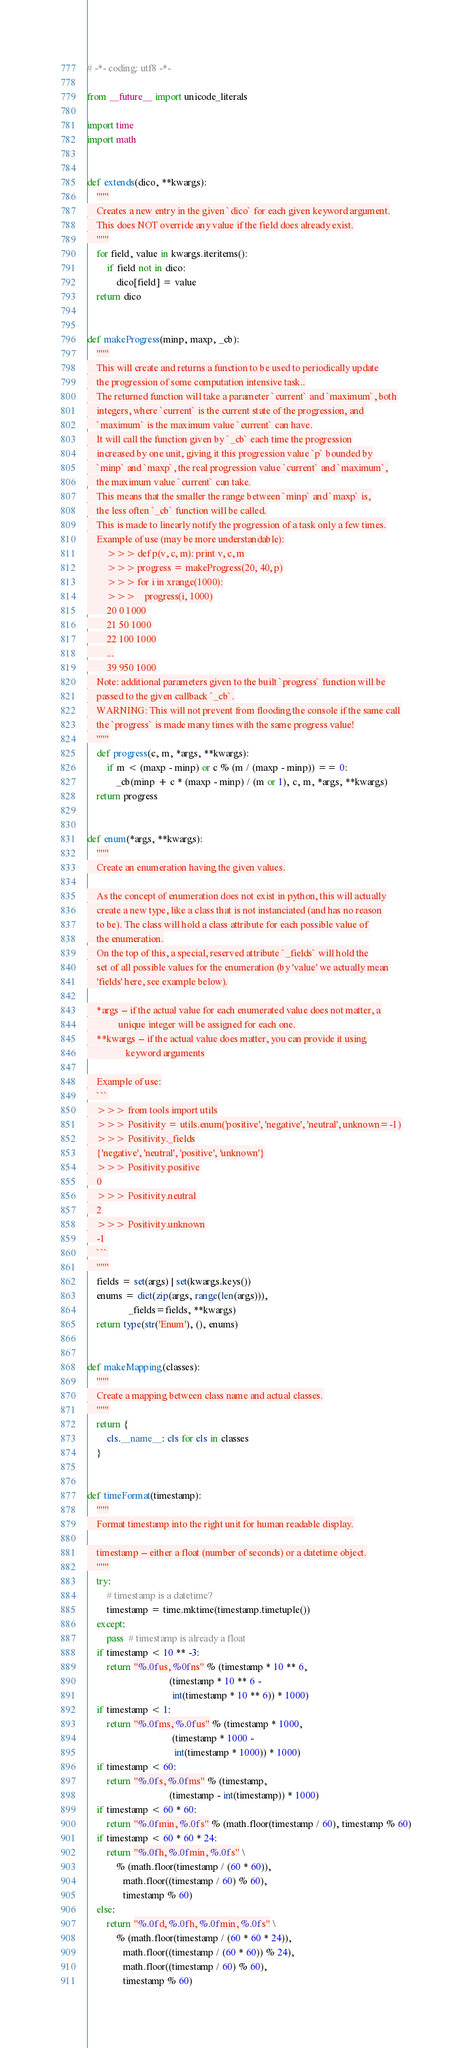<code> <loc_0><loc_0><loc_500><loc_500><_Python_># -*- coding: utf8 -*-

from __future__ import unicode_literals

import time
import math


def extends(dico, **kwargs):
    """
    Creates a new entry in the given `dico` for each given keyword argument.
    This does NOT override any value if the field does already exist.
    """
    for field, value in kwargs.iteritems():
        if field not in dico:
            dico[field] = value
    return dico


def makeProgress(minp, maxp, _cb):
    """
    This will create and returns a function to be used to periodically update
    the progression of some computation intensive task..
    The returned function will take a parameter `current` and `maximum`, both
    integers, where `current` is the current state of the progression, and
    `maximum` is the maximum value `current` can have.
    It will call the function given by `_cb` each time the progression
    increased by one unit, giving it this progression value `p` bounded by
    `minp` and `maxp`, the real progression value `current` and `maximum`,
    the maximum value `current` can take.
    This means that the smaller the range between `minp` and `maxp` is,
    the less often `_cb` function will be called.
    This is made to linearly notify the progression of a task only a few times.
    Example of use (may be more understandable):
        >>> def p(v, c, m): print v, c, m
        >>> progress = makeProgress(20, 40, p)
        >>> for i in xrange(1000):
        >>>    progress(i, 1000)
        20 0 1000
        21 50 1000
        22 100 1000
        ...
        39 950 1000
    Note: additional parameters given to the built `progress` function will be
    passed to the given callback `_cb`.
    WARNING: This will not prevent from flooding the console if the same call
    the `progress` is made many times with the same progress value!
    """
    def progress(c, m, *args, **kwargs):
        if m < (maxp - minp) or c % (m / (maxp - minp)) == 0:
            _cb(minp + c * (maxp - minp) / (m or 1), c, m, *args, **kwargs)
    return progress


def enum(*args, **kwargs):
    """
    Create an enumeration having the given values.

    As the concept of enumeration does not exist in python, this will actually
    create a new type, like a class that is not instanciated (and has no reason
    to be). The class will hold a class attribute for each possible value of
    the enumeration.
    On the top of this, a special, reserved attribute `_fields` will hold the
    set of all possible values for the enumeration (by 'value' we actually mean
    'fields' here, see example below).

    *args -- if the actual value for each enumerated value does not matter, a
             unique integer will be assigned for each one.
    **kwargs -- if the actual value does matter, you can provide it using
                keyword arguments

    Example of use:
    ```
    >>> from tools import utils
    >>> Positivity = utils.enum('positive', 'negative', 'neutral', unknown=-1)
    >>> Positivity._fields
    {'negative', 'neutral', 'positive', 'unknown'}
    >>> Positivity.positive
    0
    >>> Positivity.neutral
    2
    >>> Positivity.unknown
    -1
    ```
    """
    fields = set(args) | set(kwargs.keys())
    enums = dict(zip(args, range(len(args))),
                 _fields=fields, **kwargs)
    return type(str('Enum'), (), enums)


def makeMapping(classes):
    """
    Create a mapping between class name and actual classes.
    """
    return {
        cls.__name__: cls for cls in classes
    }


def timeFormat(timestamp):
    """
    Format timestamp into the right unit for human readable display.

    timestamp -- either a float (number of seconds) or a datetime object.
    """
    try:
        # timestamp is a datetime?
        timestamp = time.mktime(timestamp.timetuple())
    except:
        pass  # timestamp is already a float
    if timestamp < 10 ** -3:
        return "%.0fus, %0fns" % (timestamp * 10 ** 6,
                                  (timestamp * 10 ** 6 -
                                   int(timestamp * 10 ** 6)) * 1000)
    if timestamp < 1:
        return "%.0fms, %.0fus" % (timestamp * 1000,
                                   (timestamp * 1000 -
                                    int(timestamp * 1000)) * 1000)
    if timestamp < 60:
        return "%.0fs, %.0fms" % (timestamp,
                                  (timestamp - int(timestamp)) * 1000)
    if timestamp < 60 * 60:
        return "%.0fmin, %.0fs" % (math.floor(timestamp / 60), timestamp % 60)
    if timestamp < 60 * 60 * 24:
        return "%.0fh, %.0fmin, %.0fs" \
            % (math.floor(timestamp / (60 * 60)),
               math.floor((timestamp / 60) % 60),
               timestamp % 60)
    else:
        return "%.0fd, %.0fh, %.0fmin, %.0fs" \
            % (math.floor(timestamp / (60 * 60 * 24)),
               math.floor((timestamp / (60 * 60)) % 24),
               math.floor((timestamp / 60) % 60),
               timestamp % 60)
</code> 